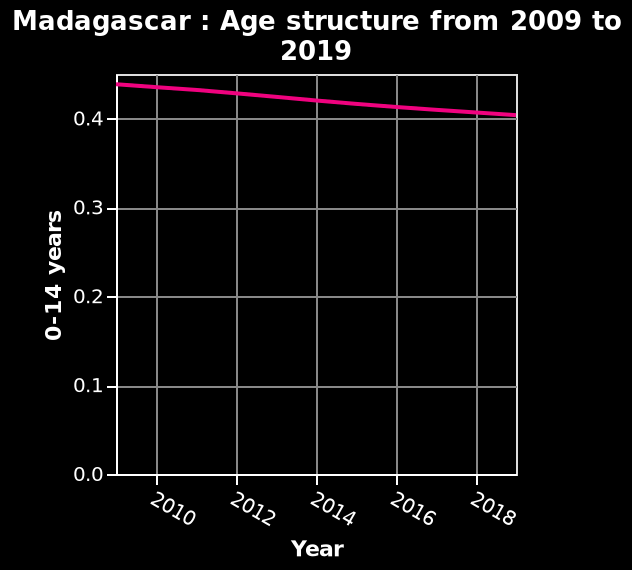<image>
What is plotted on the x-axis of the line chart? The years from 2010 to 2018. please summary the statistics and relations of the chart The age structure in Madagascar between 0-14 years has a declining trend from 0.45 in 2009 to 0.4 in 2019. What time period does the line chart represent for age structure in Madagascar? The line chart represents the age structure from 2009 to 2019. What is the current state of the age structure in Madagascar?  The age structure in Madagascar is at the lowest it has been and sits at 0.4 in 2019. 